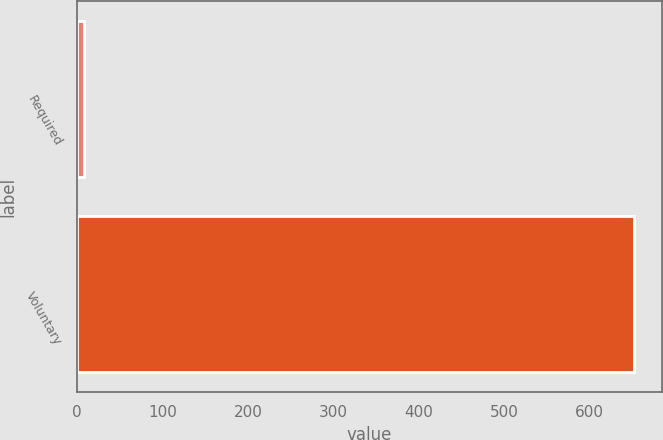Convert chart to OTSL. <chart><loc_0><loc_0><loc_500><loc_500><bar_chart><fcel>Required<fcel>Voluntary<nl><fcel>8<fcel>652<nl></chart> 